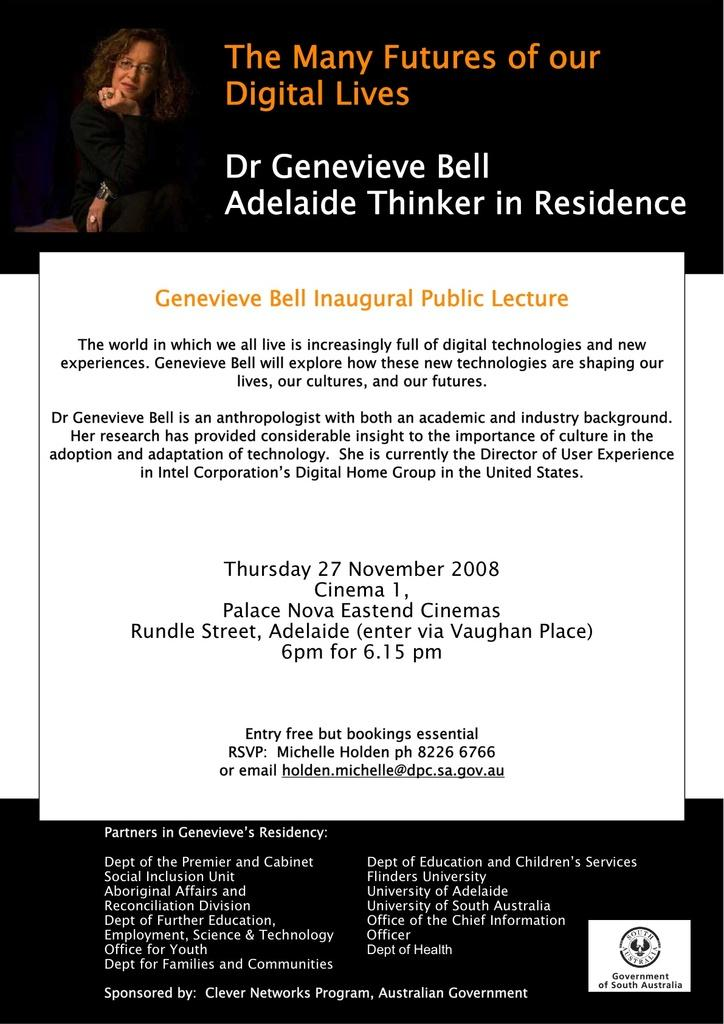What is the main subject of the image? There is an advertisement in the image. What can be seen in the advertisement? The advertisement contains a picture of a woman. What else is featured on the advertisement besides the image? There is text written on the advertisement. Is there a cobweb visible on the woman's face in the advertisement? There is no cobweb visible on the woman's face in the advertisement. What type of education is being promoted in the advertisement? The advertisement does not mention or promote any type of education. 